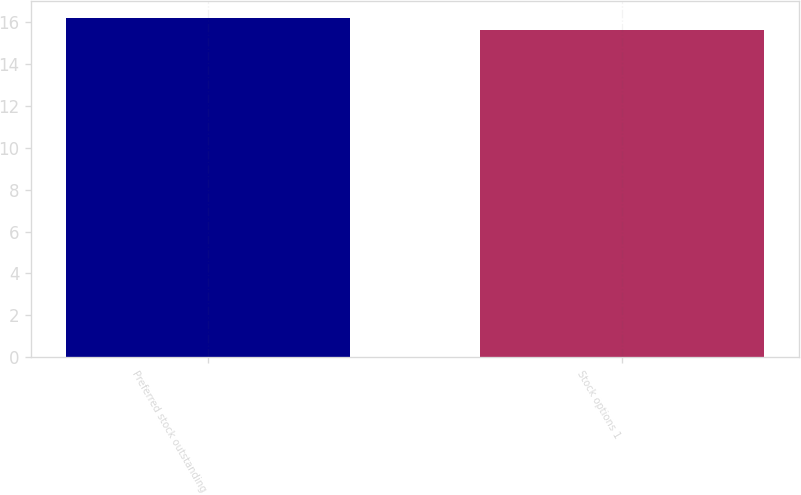<chart> <loc_0><loc_0><loc_500><loc_500><bar_chart><fcel>Preferred stock outstanding<fcel>Stock options 1<nl><fcel>16.2<fcel>15.6<nl></chart> 